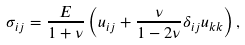<formula> <loc_0><loc_0><loc_500><loc_500>\sigma _ { i j } = \frac { E } { 1 + \nu } \left ( u _ { i j } + \frac { \nu } { 1 - 2 \nu } \delta _ { i j } u _ { k k } \right ) ,</formula> 